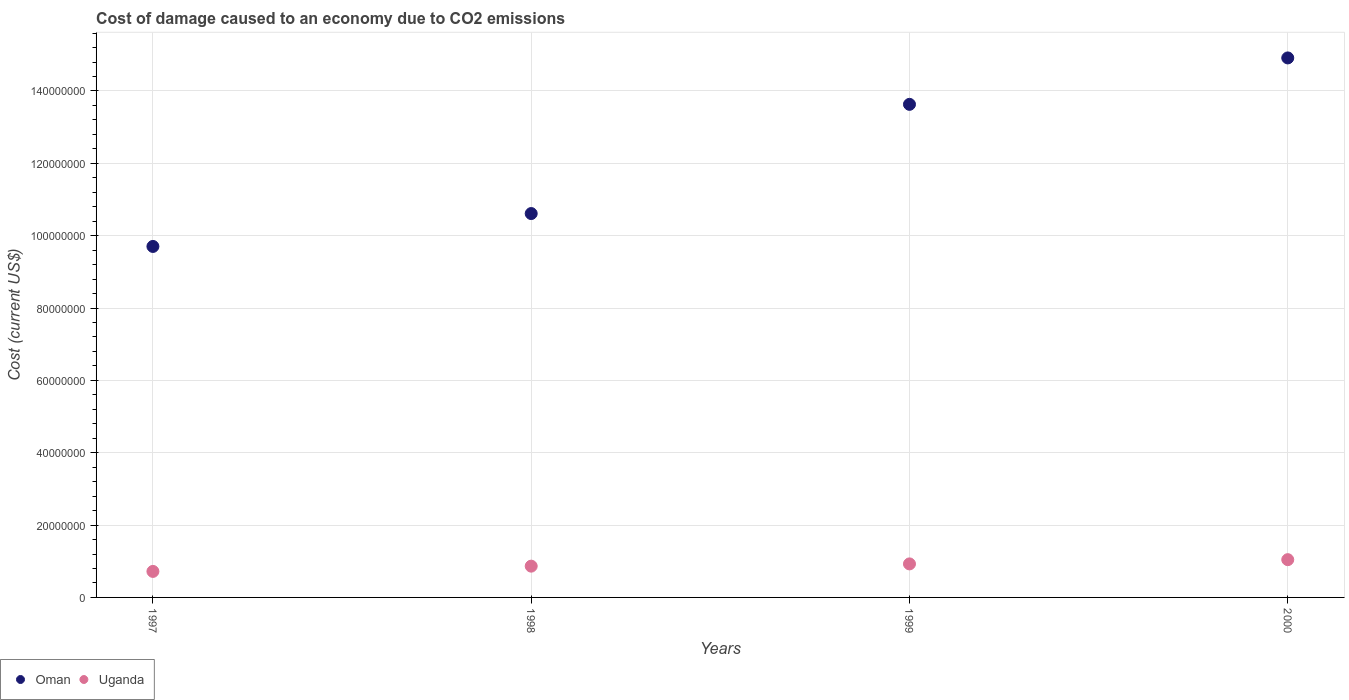How many different coloured dotlines are there?
Provide a succinct answer. 2. Is the number of dotlines equal to the number of legend labels?
Your answer should be compact. Yes. What is the cost of damage caused due to CO2 emissisons in Oman in 1999?
Offer a terse response. 1.36e+08. Across all years, what is the maximum cost of damage caused due to CO2 emissisons in Oman?
Give a very brief answer. 1.49e+08. Across all years, what is the minimum cost of damage caused due to CO2 emissisons in Uganda?
Give a very brief answer. 7.19e+06. In which year was the cost of damage caused due to CO2 emissisons in Oman maximum?
Provide a succinct answer. 2000. What is the total cost of damage caused due to CO2 emissisons in Uganda in the graph?
Your response must be concise. 3.55e+07. What is the difference between the cost of damage caused due to CO2 emissisons in Uganda in 1997 and that in 1998?
Keep it short and to the point. -1.46e+06. What is the difference between the cost of damage caused due to CO2 emissisons in Oman in 1999 and the cost of damage caused due to CO2 emissisons in Uganda in 2000?
Keep it short and to the point. 1.26e+08. What is the average cost of damage caused due to CO2 emissisons in Uganda per year?
Offer a very short reply. 8.89e+06. In the year 1999, what is the difference between the cost of damage caused due to CO2 emissisons in Oman and cost of damage caused due to CO2 emissisons in Uganda?
Give a very brief answer. 1.27e+08. In how many years, is the cost of damage caused due to CO2 emissisons in Uganda greater than 84000000 US$?
Offer a very short reply. 0. What is the ratio of the cost of damage caused due to CO2 emissisons in Oman in 1998 to that in 1999?
Your response must be concise. 0.78. Is the cost of damage caused due to CO2 emissisons in Uganda in 1998 less than that in 2000?
Offer a very short reply. Yes. Is the difference between the cost of damage caused due to CO2 emissisons in Oman in 1997 and 2000 greater than the difference between the cost of damage caused due to CO2 emissisons in Uganda in 1997 and 2000?
Your answer should be very brief. No. What is the difference between the highest and the second highest cost of damage caused due to CO2 emissisons in Oman?
Give a very brief answer. 1.28e+07. What is the difference between the highest and the lowest cost of damage caused due to CO2 emissisons in Uganda?
Give a very brief answer. 3.25e+06. In how many years, is the cost of damage caused due to CO2 emissisons in Oman greater than the average cost of damage caused due to CO2 emissisons in Oman taken over all years?
Ensure brevity in your answer.  2. Does the cost of damage caused due to CO2 emissisons in Oman monotonically increase over the years?
Offer a very short reply. Yes. Is the cost of damage caused due to CO2 emissisons in Uganda strictly greater than the cost of damage caused due to CO2 emissisons in Oman over the years?
Your answer should be compact. No. Is the cost of damage caused due to CO2 emissisons in Uganda strictly less than the cost of damage caused due to CO2 emissisons in Oman over the years?
Provide a short and direct response. Yes. How many dotlines are there?
Your answer should be very brief. 2. Are the values on the major ticks of Y-axis written in scientific E-notation?
Make the answer very short. No. Does the graph contain any zero values?
Ensure brevity in your answer.  No. What is the title of the graph?
Keep it short and to the point. Cost of damage caused to an economy due to CO2 emissions. Does "Iraq" appear as one of the legend labels in the graph?
Offer a very short reply. No. What is the label or title of the X-axis?
Provide a succinct answer. Years. What is the label or title of the Y-axis?
Keep it short and to the point. Cost (current US$). What is the Cost (current US$) in Oman in 1997?
Provide a succinct answer. 9.70e+07. What is the Cost (current US$) of Uganda in 1997?
Make the answer very short. 7.19e+06. What is the Cost (current US$) in Oman in 1998?
Offer a very short reply. 1.06e+08. What is the Cost (current US$) of Uganda in 1998?
Make the answer very short. 8.65e+06. What is the Cost (current US$) of Oman in 1999?
Give a very brief answer. 1.36e+08. What is the Cost (current US$) in Uganda in 1999?
Your answer should be compact. 9.27e+06. What is the Cost (current US$) in Oman in 2000?
Your answer should be very brief. 1.49e+08. What is the Cost (current US$) of Uganda in 2000?
Offer a terse response. 1.04e+07. Across all years, what is the maximum Cost (current US$) of Oman?
Provide a succinct answer. 1.49e+08. Across all years, what is the maximum Cost (current US$) in Uganda?
Keep it short and to the point. 1.04e+07. Across all years, what is the minimum Cost (current US$) in Oman?
Offer a very short reply. 9.70e+07. Across all years, what is the minimum Cost (current US$) of Uganda?
Offer a terse response. 7.19e+06. What is the total Cost (current US$) in Oman in the graph?
Keep it short and to the point. 4.89e+08. What is the total Cost (current US$) of Uganda in the graph?
Offer a very short reply. 3.55e+07. What is the difference between the Cost (current US$) in Oman in 1997 and that in 1998?
Your answer should be compact. -9.09e+06. What is the difference between the Cost (current US$) in Uganda in 1997 and that in 1998?
Provide a short and direct response. -1.46e+06. What is the difference between the Cost (current US$) in Oman in 1997 and that in 1999?
Your answer should be very brief. -3.93e+07. What is the difference between the Cost (current US$) in Uganda in 1997 and that in 1999?
Keep it short and to the point. -2.08e+06. What is the difference between the Cost (current US$) of Oman in 1997 and that in 2000?
Provide a succinct answer. -5.21e+07. What is the difference between the Cost (current US$) of Uganda in 1997 and that in 2000?
Provide a succinct answer. -3.25e+06. What is the difference between the Cost (current US$) of Oman in 1998 and that in 1999?
Provide a short and direct response. -3.02e+07. What is the difference between the Cost (current US$) in Uganda in 1998 and that in 1999?
Keep it short and to the point. -6.22e+05. What is the difference between the Cost (current US$) of Oman in 1998 and that in 2000?
Ensure brevity in your answer.  -4.30e+07. What is the difference between the Cost (current US$) in Uganda in 1998 and that in 2000?
Offer a terse response. -1.79e+06. What is the difference between the Cost (current US$) in Oman in 1999 and that in 2000?
Offer a very short reply. -1.28e+07. What is the difference between the Cost (current US$) in Uganda in 1999 and that in 2000?
Provide a succinct answer. -1.17e+06. What is the difference between the Cost (current US$) of Oman in 1997 and the Cost (current US$) of Uganda in 1998?
Provide a succinct answer. 8.84e+07. What is the difference between the Cost (current US$) of Oman in 1997 and the Cost (current US$) of Uganda in 1999?
Ensure brevity in your answer.  8.77e+07. What is the difference between the Cost (current US$) in Oman in 1997 and the Cost (current US$) in Uganda in 2000?
Offer a very short reply. 8.66e+07. What is the difference between the Cost (current US$) of Oman in 1998 and the Cost (current US$) of Uganda in 1999?
Make the answer very short. 9.68e+07. What is the difference between the Cost (current US$) of Oman in 1998 and the Cost (current US$) of Uganda in 2000?
Your response must be concise. 9.57e+07. What is the difference between the Cost (current US$) in Oman in 1999 and the Cost (current US$) in Uganda in 2000?
Offer a terse response. 1.26e+08. What is the average Cost (current US$) in Oman per year?
Your response must be concise. 1.22e+08. What is the average Cost (current US$) in Uganda per year?
Offer a very short reply. 8.89e+06. In the year 1997, what is the difference between the Cost (current US$) in Oman and Cost (current US$) in Uganda?
Provide a short and direct response. 8.98e+07. In the year 1998, what is the difference between the Cost (current US$) of Oman and Cost (current US$) of Uganda?
Offer a very short reply. 9.75e+07. In the year 1999, what is the difference between the Cost (current US$) in Oman and Cost (current US$) in Uganda?
Keep it short and to the point. 1.27e+08. In the year 2000, what is the difference between the Cost (current US$) in Oman and Cost (current US$) in Uganda?
Give a very brief answer. 1.39e+08. What is the ratio of the Cost (current US$) of Oman in 1997 to that in 1998?
Offer a terse response. 0.91. What is the ratio of the Cost (current US$) of Uganda in 1997 to that in 1998?
Give a very brief answer. 0.83. What is the ratio of the Cost (current US$) of Oman in 1997 to that in 1999?
Keep it short and to the point. 0.71. What is the ratio of the Cost (current US$) in Uganda in 1997 to that in 1999?
Keep it short and to the point. 0.78. What is the ratio of the Cost (current US$) of Oman in 1997 to that in 2000?
Keep it short and to the point. 0.65. What is the ratio of the Cost (current US$) in Uganda in 1997 to that in 2000?
Your answer should be compact. 0.69. What is the ratio of the Cost (current US$) in Oman in 1998 to that in 1999?
Give a very brief answer. 0.78. What is the ratio of the Cost (current US$) of Uganda in 1998 to that in 1999?
Your response must be concise. 0.93. What is the ratio of the Cost (current US$) in Oman in 1998 to that in 2000?
Offer a terse response. 0.71. What is the ratio of the Cost (current US$) of Uganda in 1998 to that in 2000?
Offer a very short reply. 0.83. What is the ratio of the Cost (current US$) in Oman in 1999 to that in 2000?
Provide a succinct answer. 0.91. What is the ratio of the Cost (current US$) in Uganda in 1999 to that in 2000?
Your answer should be very brief. 0.89. What is the difference between the highest and the second highest Cost (current US$) in Oman?
Your answer should be compact. 1.28e+07. What is the difference between the highest and the second highest Cost (current US$) in Uganda?
Ensure brevity in your answer.  1.17e+06. What is the difference between the highest and the lowest Cost (current US$) in Oman?
Your answer should be compact. 5.21e+07. What is the difference between the highest and the lowest Cost (current US$) in Uganda?
Provide a succinct answer. 3.25e+06. 